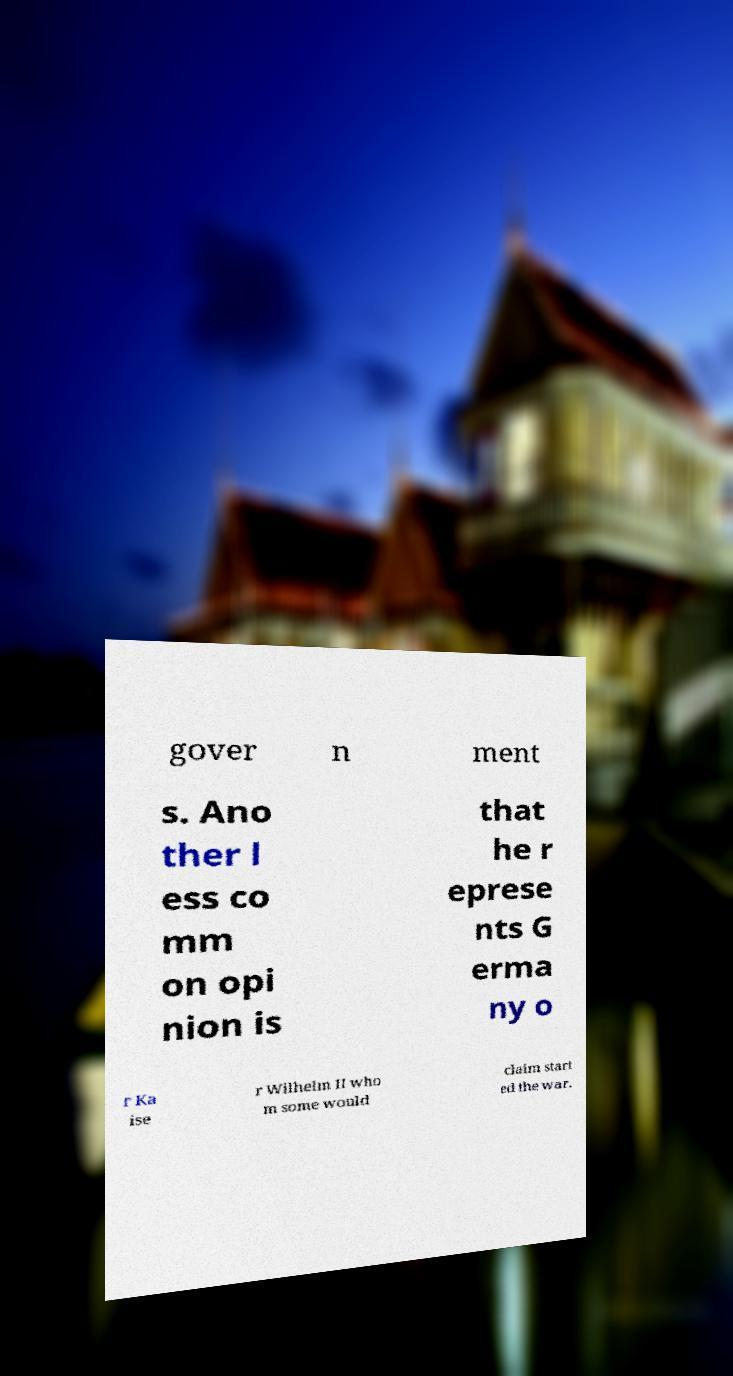Please read and relay the text visible in this image. What does it say? gover n ment s. Ano ther l ess co mm on opi nion is that he r eprese nts G erma ny o r Ka ise r Wilhelm II who m some would claim start ed the war. 